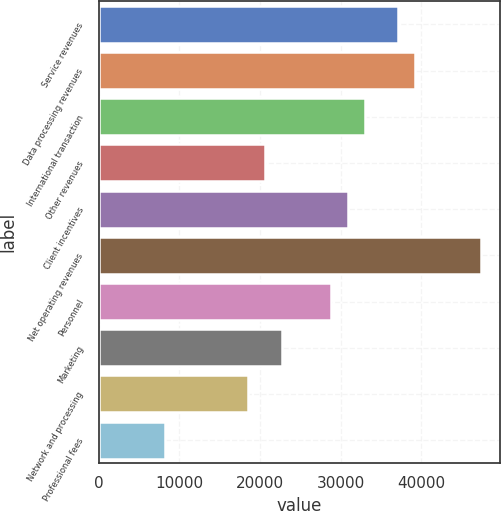<chart> <loc_0><loc_0><loc_500><loc_500><bar_chart><fcel>Service revenues<fcel>Data processing revenues<fcel>International transaction<fcel>Other revenues<fcel>Client incentives<fcel>Net operating revenues<fcel>Personnel<fcel>Marketing<fcel>Network and processing<fcel>Professional fees<nl><fcel>37092.7<fcel>39153.2<fcel>32971.8<fcel>20609<fcel>30911.3<fcel>47395<fcel>28850.9<fcel>22669.5<fcel>18548.6<fcel>8246.27<nl></chart> 